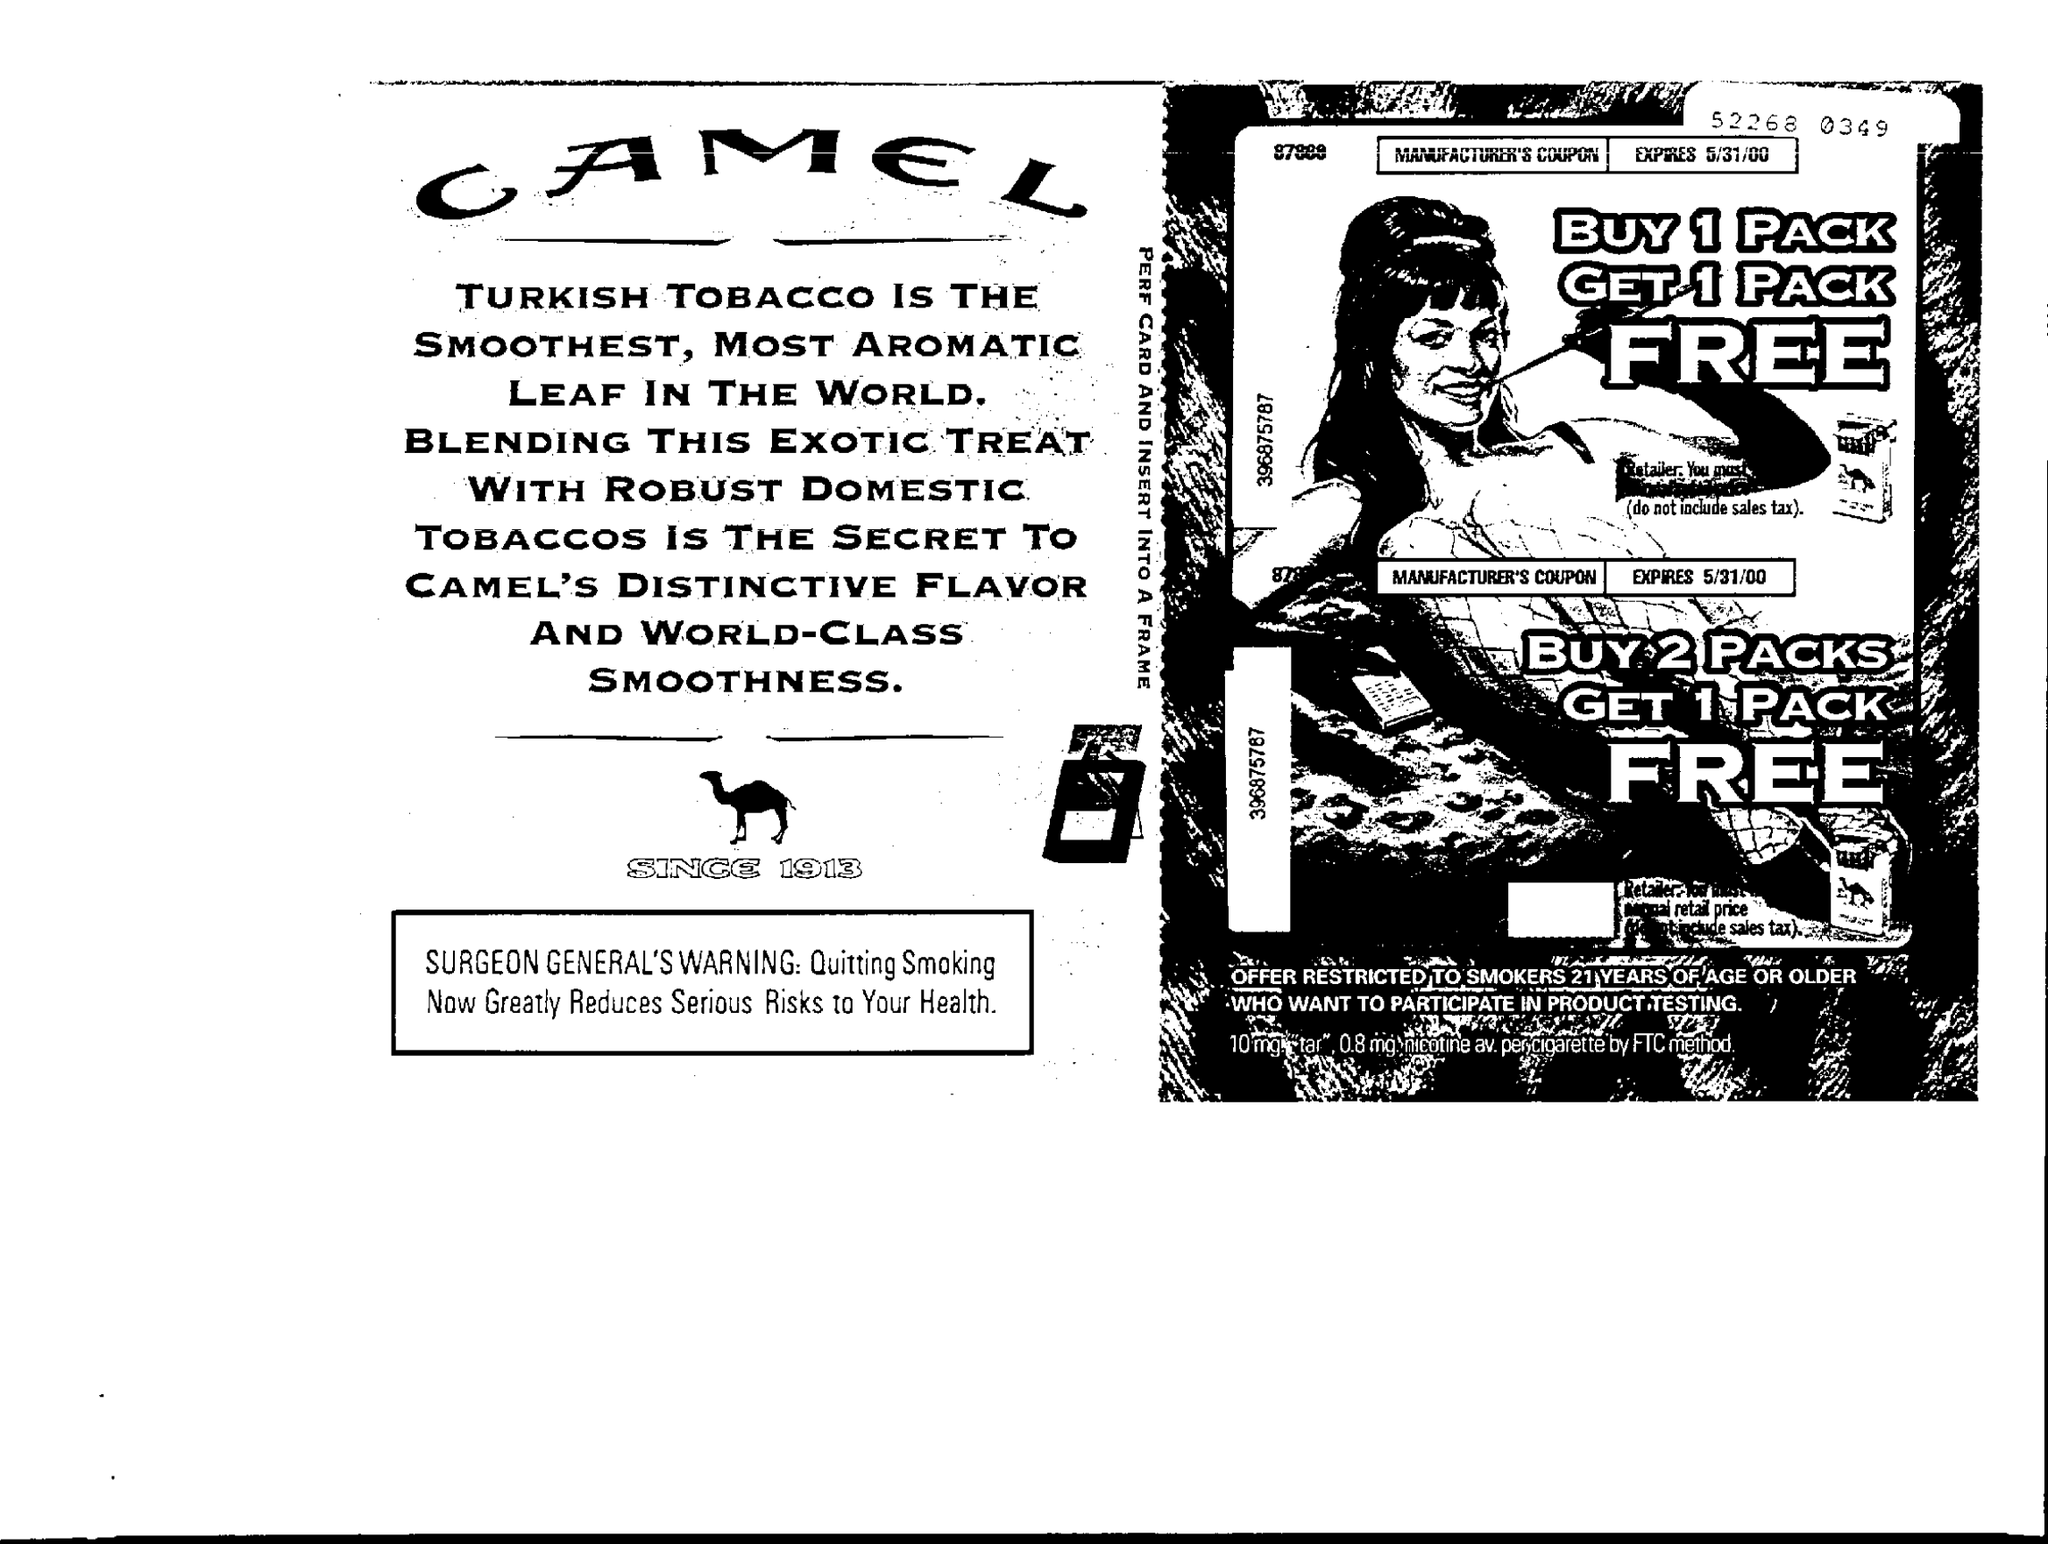Give some essential details in this illustration. The coupon is set to expire on May 31, 2000. 